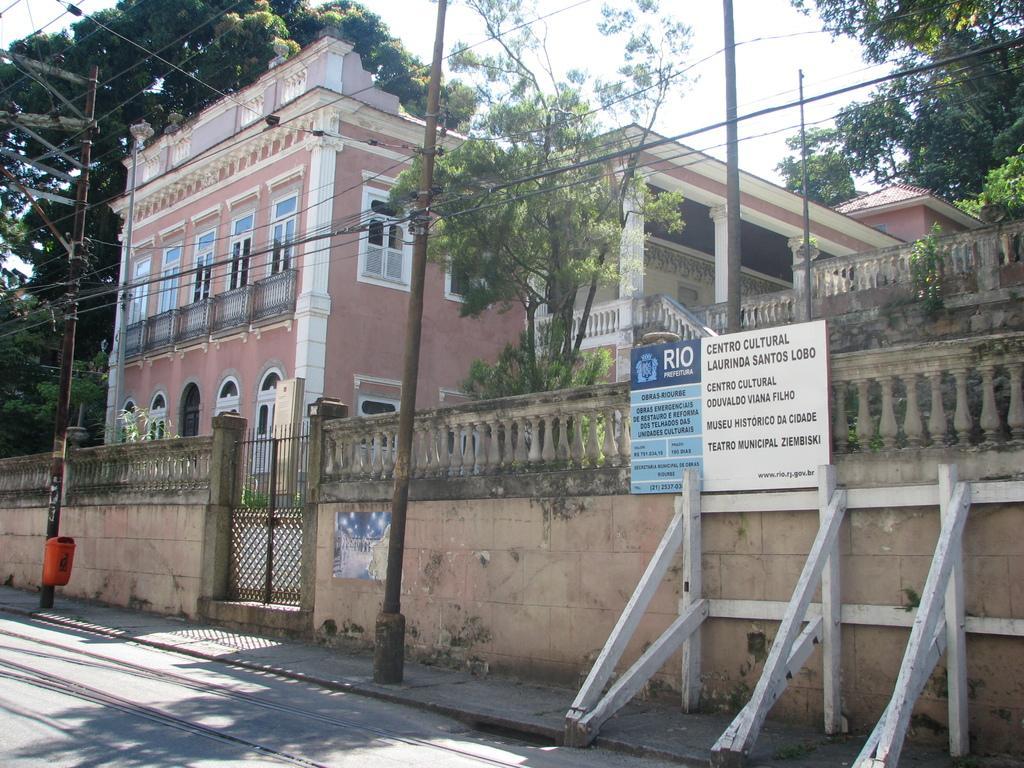Could you give a brief overview of what you see in this image? In this image in the front there are poles and there is a railing and on the railing there is some text written on it. In the background there is a building and there are trees and there are wires in front of the building attached to the poles. 